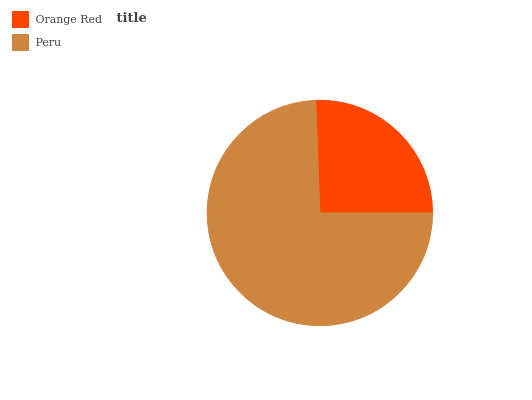Is Orange Red the minimum?
Answer yes or no. Yes. Is Peru the maximum?
Answer yes or no. Yes. Is Peru the minimum?
Answer yes or no. No. Is Peru greater than Orange Red?
Answer yes or no. Yes. Is Orange Red less than Peru?
Answer yes or no. Yes. Is Orange Red greater than Peru?
Answer yes or no. No. Is Peru less than Orange Red?
Answer yes or no. No. Is Peru the high median?
Answer yes or no. Yes. Is Orange Red the low median?
Answer yes or no. Yes. Is Orange Red the high median?
Answer yes or no. No. Is Peru the low median?
Answer yes or no. No. 